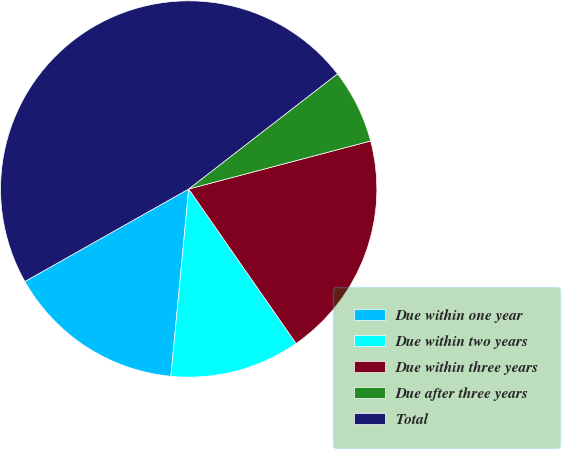Convert chart to OTSL. <chart><loc_0><loc_0><loc_500><loc_500><pie_chart><fcel>Due within one year<fcel>Due within two years<fcel>Due within three years<fcel>Due after three years<fcel>Total<nl><fcel>15.31%<fcel>11.18%<fcel>19.44%<fcel>6.38%<fcel>47.7%<nl></chart> 